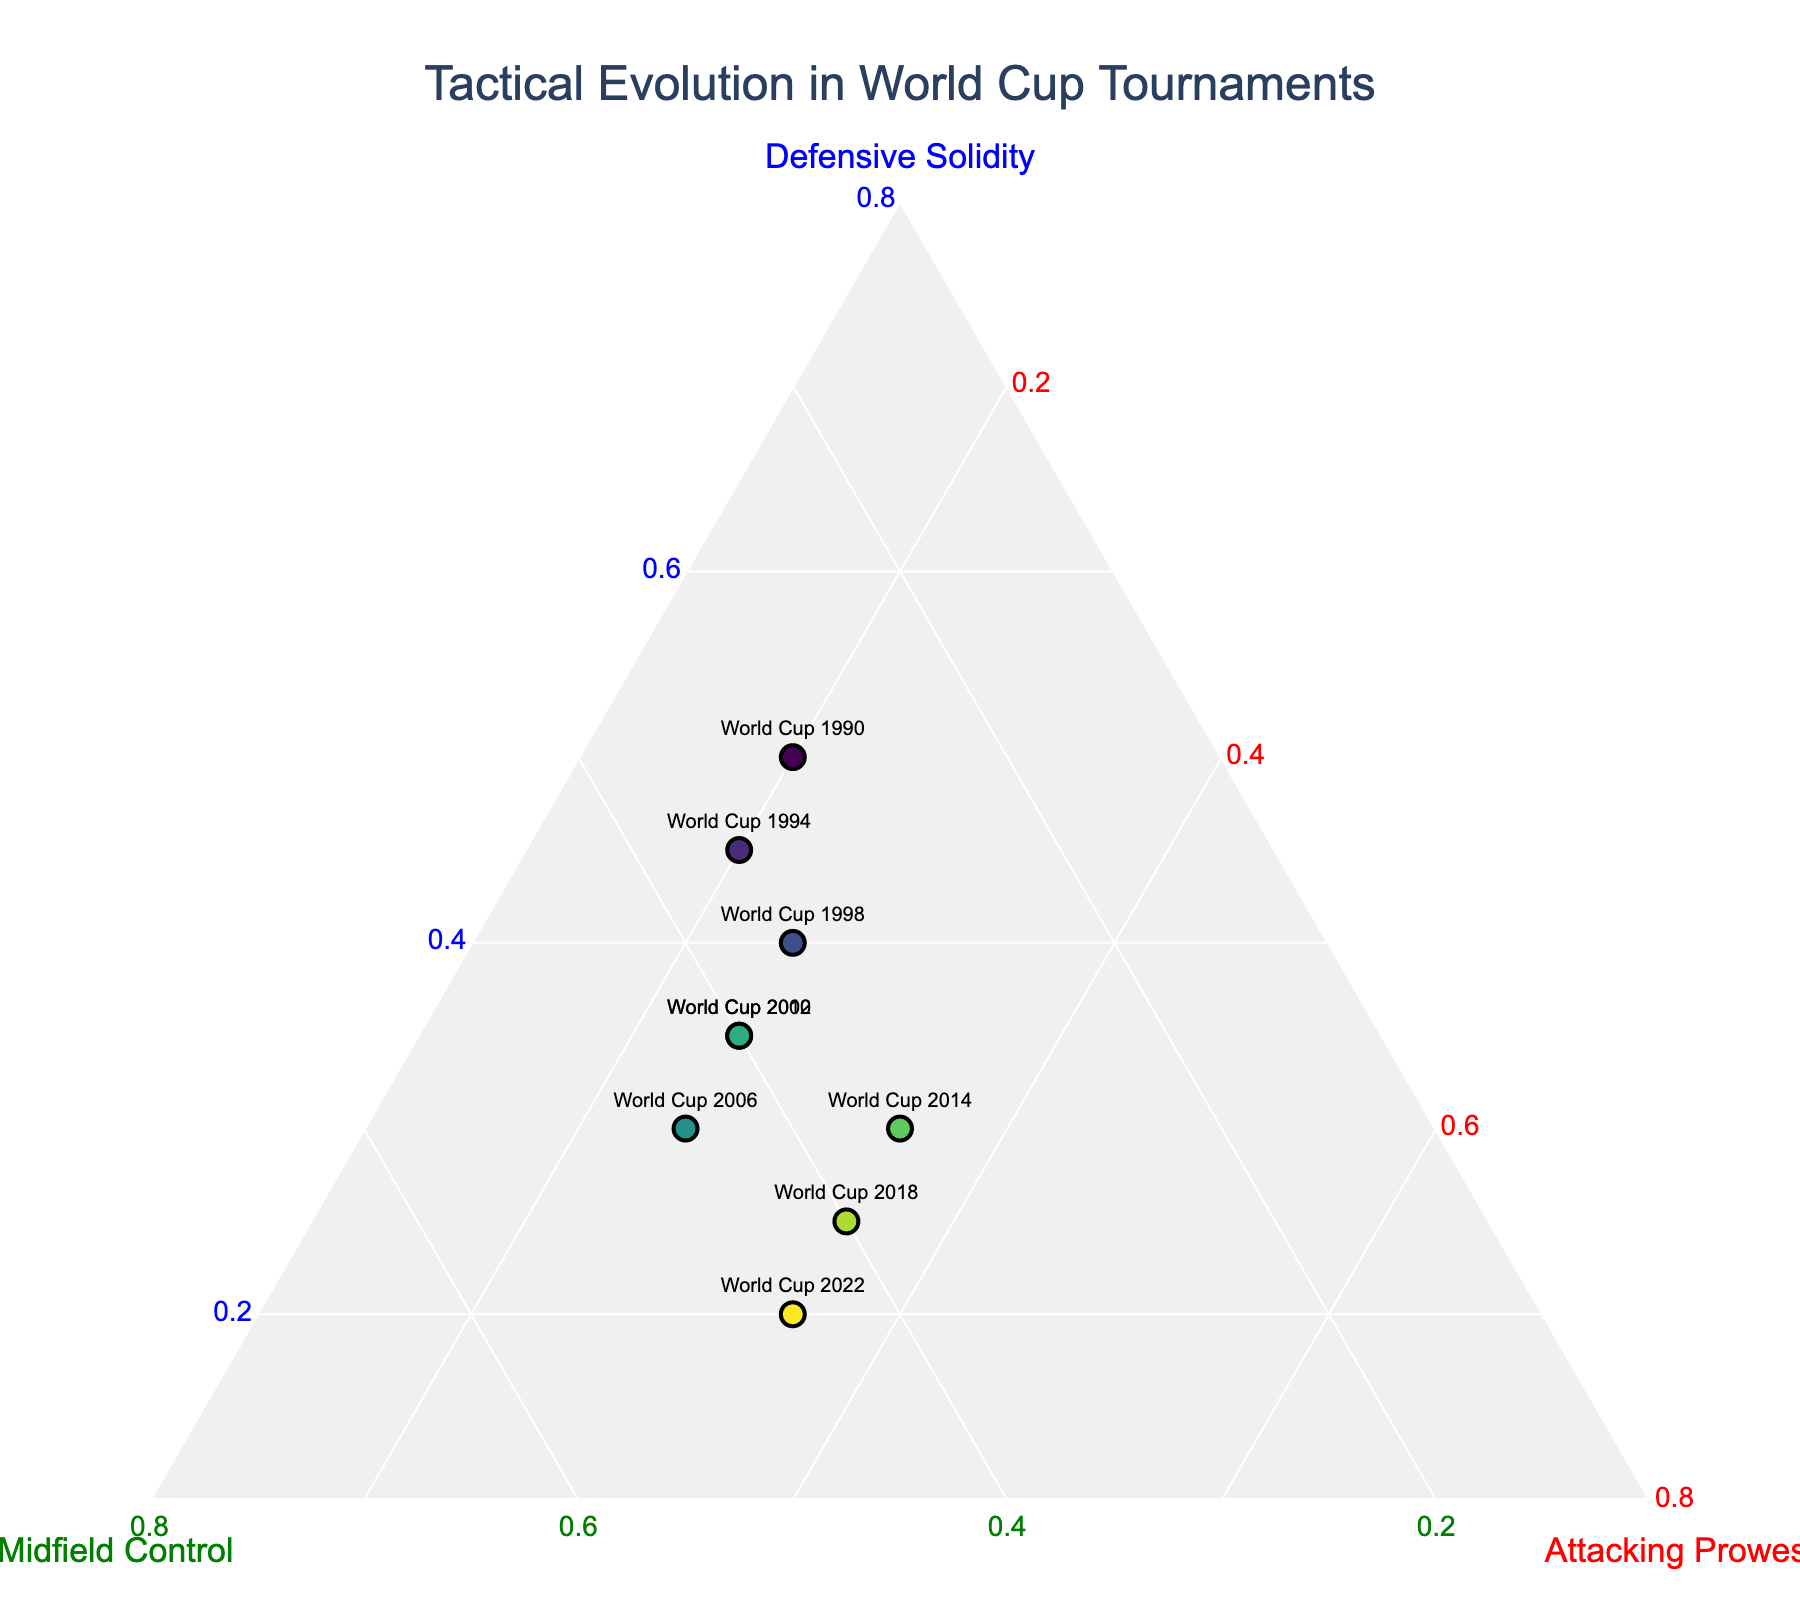What is the title of the plot? The title of the plot is prominently displayed in large font at the top of the figure, indicating the plot's main subject.
Answer: Tactical Evolution in World Cup Tournaments How many data points are represented in the plot? Each data point corresponds to a World Cup tournament from 1990 to 2022. Counting these, we get 9 data points.
Answer: 9 Which axis represents 'Midfield Control'? The ternary plot has three axes, each corresponding to one of the dimensions: Defensive Solidity, Midfield Control, and Attacking Prowess. The green-colored axis indicates Midfield Control.
Answer: Green axis What is the highest value for 'Defensive Solidity,' and which tournament does it correspond to? By examining the plot, the World Cup 1990 has the highest percentage for Defensive Solidity, which is 50%.
Answer: World Cup 1990 Which tournament shows a balance between 'Midfield Control' and 'Attacking Prowess'? From the ternary plot, the World Cup 2014 shows the closest balance where the values for Midfield Control and Attacking Prowess are both 35%.
Answer: World Cup 2014 How did the 'Defensive Solidity' values trend from 1990 to 2022? Observing the progression of points from 1990 to 2022, there is a noticeable downward trend in the values of Defensive Solidity, progressively decreasing in each tournament.
Answer: Downward trend Which World Cup tournament had the same values for 'Midfield Control' as 'Attacking Prowess,' and what were those values? On examining the ternary plot, the World Cup 2014 had equal values of 35% for both Midfield Control and Attacking Prowess.
Answer: World Cup 2014, 35% What can be inferred about the overall tactical strategy evolution from 1990 to 2022? Analyzing the ternary plot, it can be seen that there is a shift from Defensive Solidity dominating earlier tournaments to a more balanced approach, with increasing emphasis on Midfield Control and Attacking Prowess in recent tournaments.
Answer: Shift to balanced approach Which World Cup tournament had the lowest value for 'Defensive Solidity' and what was the value? By looking at the plot, the World Cup 2022 has the lowest value for Defensive Solidity, which is 20%.
Answer: World Cup 2022, 20% 